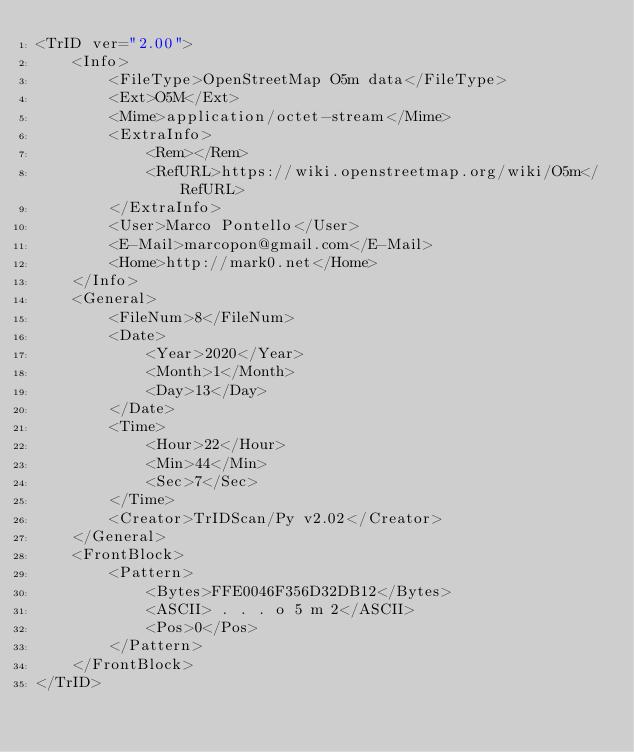Convert code to text. <code><loc_0><loc_0><loc_500><loc_500><_XML_><TrID ver="2.00">
	<Info>
		<FileType>OpenStreetMap O5m data</FileType>
		<Ext>O5M</Ext>
		<Mime>application/octet-stream</Mime>
		<ExtraInfo>
			<Rem></Rem>
			<RefURL>https://wiki.openstreetmap.org/wiki/O5m</RefURL>
		</ExtraInfo>
		<User>Marco Pontello</User>
		<E-Mail>marcopon@gmail.com</E-Mail>
		<Home>http://mark0.net</Home>
	</Info>
	<General>
		<FileNum>8</FileNum>
		<Date>
			<Year>2020</Year>
			<Month>1</Month>
			<Day>13</Day>
		</Date>
		<Time>
			<Hour>22</Hour>
			<Min>44</Min>
			<Sec>7</Sec>
		</Time>
		<Creator>TrIDScan/Py v2.02</Creator>
	</General>
	<FrontBlock>
		<Pattern>
			<Bytes>FFE0046F356D32DB12</Bytes>
			<ASCII> . . . o 5 m 2</ASCII>
			<Pos>0</Pos>
		</Pattern>
	</FrontBlock>
</TrID></code> 